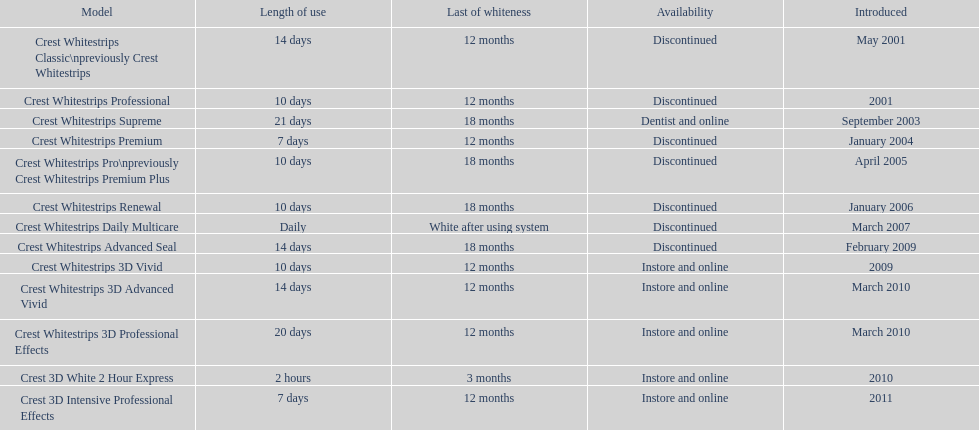How many products have been discontinued? 7. 